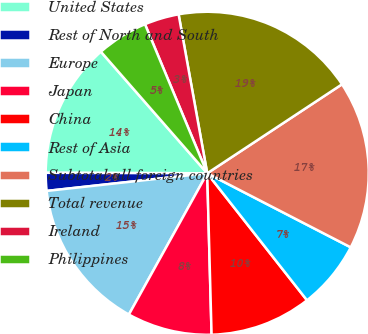<chart> <loc_0><loc_0><loc_500><loc_500><pie_chart><fcel>United States<fcel>Rest of North and South<fcel>Europe<fcel>Japan<fcel>China<fcel>Rest of Asia<fcel>Subtotal all foreign countries<fcel>Total revenue<fcel>Ireland<fcel>Philippines<nl><fcel>13.52%<fcel>1.79%<fcel>15.2%<fcel>8.49%<fcel>10.17%<fcel>6.82%<fcel>16.87%<fcel>18.55%<fcel>3.46%<fcel>5.14%<nl></chart> 